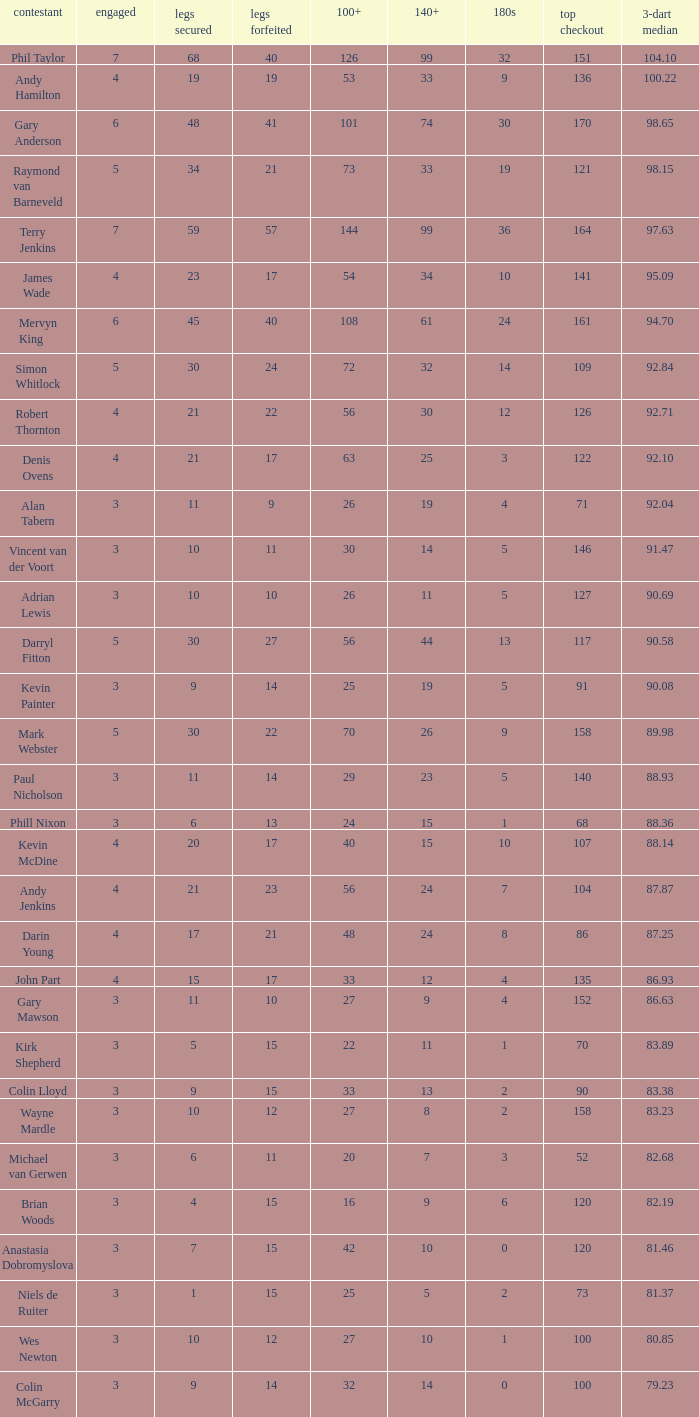Parse the full table. {'header': ['contestant', 'engaged', 'legs secured', 'legs forfeited', '100+', '140+', '180s', 'top checkout', '3-dart median'], 'rows': [['Phil Taylor', '7', '68', '40', '126', '99', '32', '151', '104.10'], ['Andy Hamilton', '4', '19', '19', '53', '33', '9', '136', '100.22'], ['Gary Anderson', '6', '48', '41', '101', '74', '30', '170', '98.65'], ['Raymond van Barneveld', '5', '34', '21', '73', '33', '19', '121', '98.15'], ['Terry Jenkins', '7', '59', '57', '144', '99', '36', '164', '97.63'], ['James Wade', '4', '23', '17', '54', '34', '10', '141', '95.09'], ['Mervyn King', '6', '45', '40', '108', '61', '24', '161', '94.70'], ['Simon Whitlock', '5', '30', '24', '72', '32', '14', '109', '92.84'], ['Robert Thornton', '4', '21', '22', '56', '30', '12', '126', '92.71'], ['Denis Ovens', '4', '21', '17', '63', '25', '3', '122', '92.10'], ['Alan Tabern', '3', '11', '9', '26', '19', '4', '71', '92.04'], ['Vincent van der Voort', '3', '10', '11', '30', '14', '5', '146', '91.47'], ['Adrian Lewis', '3', '10', '10', '26', '11', '5', '127', '90.69'], ['Darryl Fitton', '5', '30', '27', '56', '44', '13', '117', '90.58'], ['Kevin Painter', '3', '9', '14', '25', '19', '5', '91', '90.08'], ['Mark Webster', '5', '30', '22', '70', '26', '9', '158', '89.98'], ['Paul Nicholson', '3', '11', '14', '29', '23', '5', '140', '88.93'], ['Phill Nixon', '3', '6', '13', '24', '15', '1', '68', '88.36'], ['Kevin McDine', '4', '20', '17', '40', '15', '10', '107', '88.14'], ['Andy Jenkins', '4', '21', '23', '56', '24', '7', '104', '87.87'], ['Darin Young', '4', '17', '21', '48', '24', '8', '86', '87.25'], ['John Part', '4', '15', '17', '33', '12', '4', '135', '86.93'], ['Gary Mawson', '3', '11', '10', '27', '9', '4', '152', '86.63'], ['Kirk Shepherd', '3', '5', '15', '22', '11', '1', '70', '83.89'], ['Colin Lloyd', '3', '9', '15', '33', '13', '2', '90', '83.38'], ['Wayne Mardle', '3', '10', '12', '27', '8', '2', '158', '83.23'], ['Michael van Gerwen', '3', '6', '11', '20', '7', '3', '52', '82.68'], ['Brian Woods', '3', '4', '15', '16', '9', '6', '120', '82.19'], ['Anastasia Dobromyslova', '3', '7', '15', '42', '10', '0', '120', '81.46'], ['Niels de Ruiter', '3', '1', '15', '25', '5', '2', '73', '81.37'], ['Wes Newton', '3', '10', '12', '27', '10', '1', '100', '80.85'], ['Colin McGarry', '3', '9', '14', '32', '14', '0', '100', '79.23']]} What is the number of high checkout when legs Lost is 17, 140+ is 15, and played is larger than 4? None. 